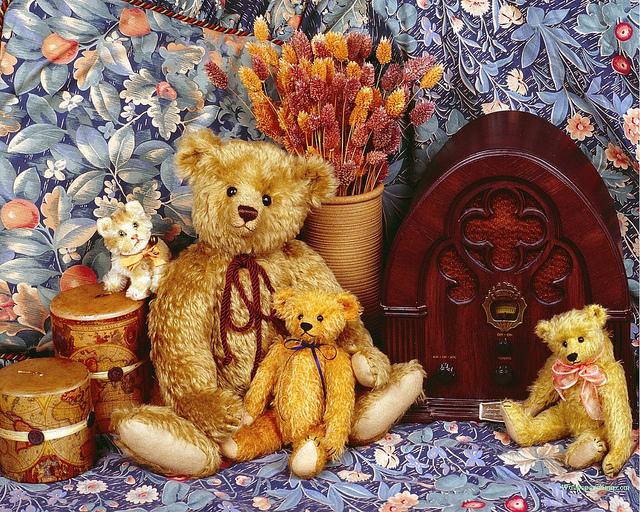Did the bears adopt the cat into the family?
Give a very brief answer. Yes. What color ribbon does the bear on the far right have?
Short answer required. Pink. What design is on the backdrop?
Write a very short answer. Floral. 